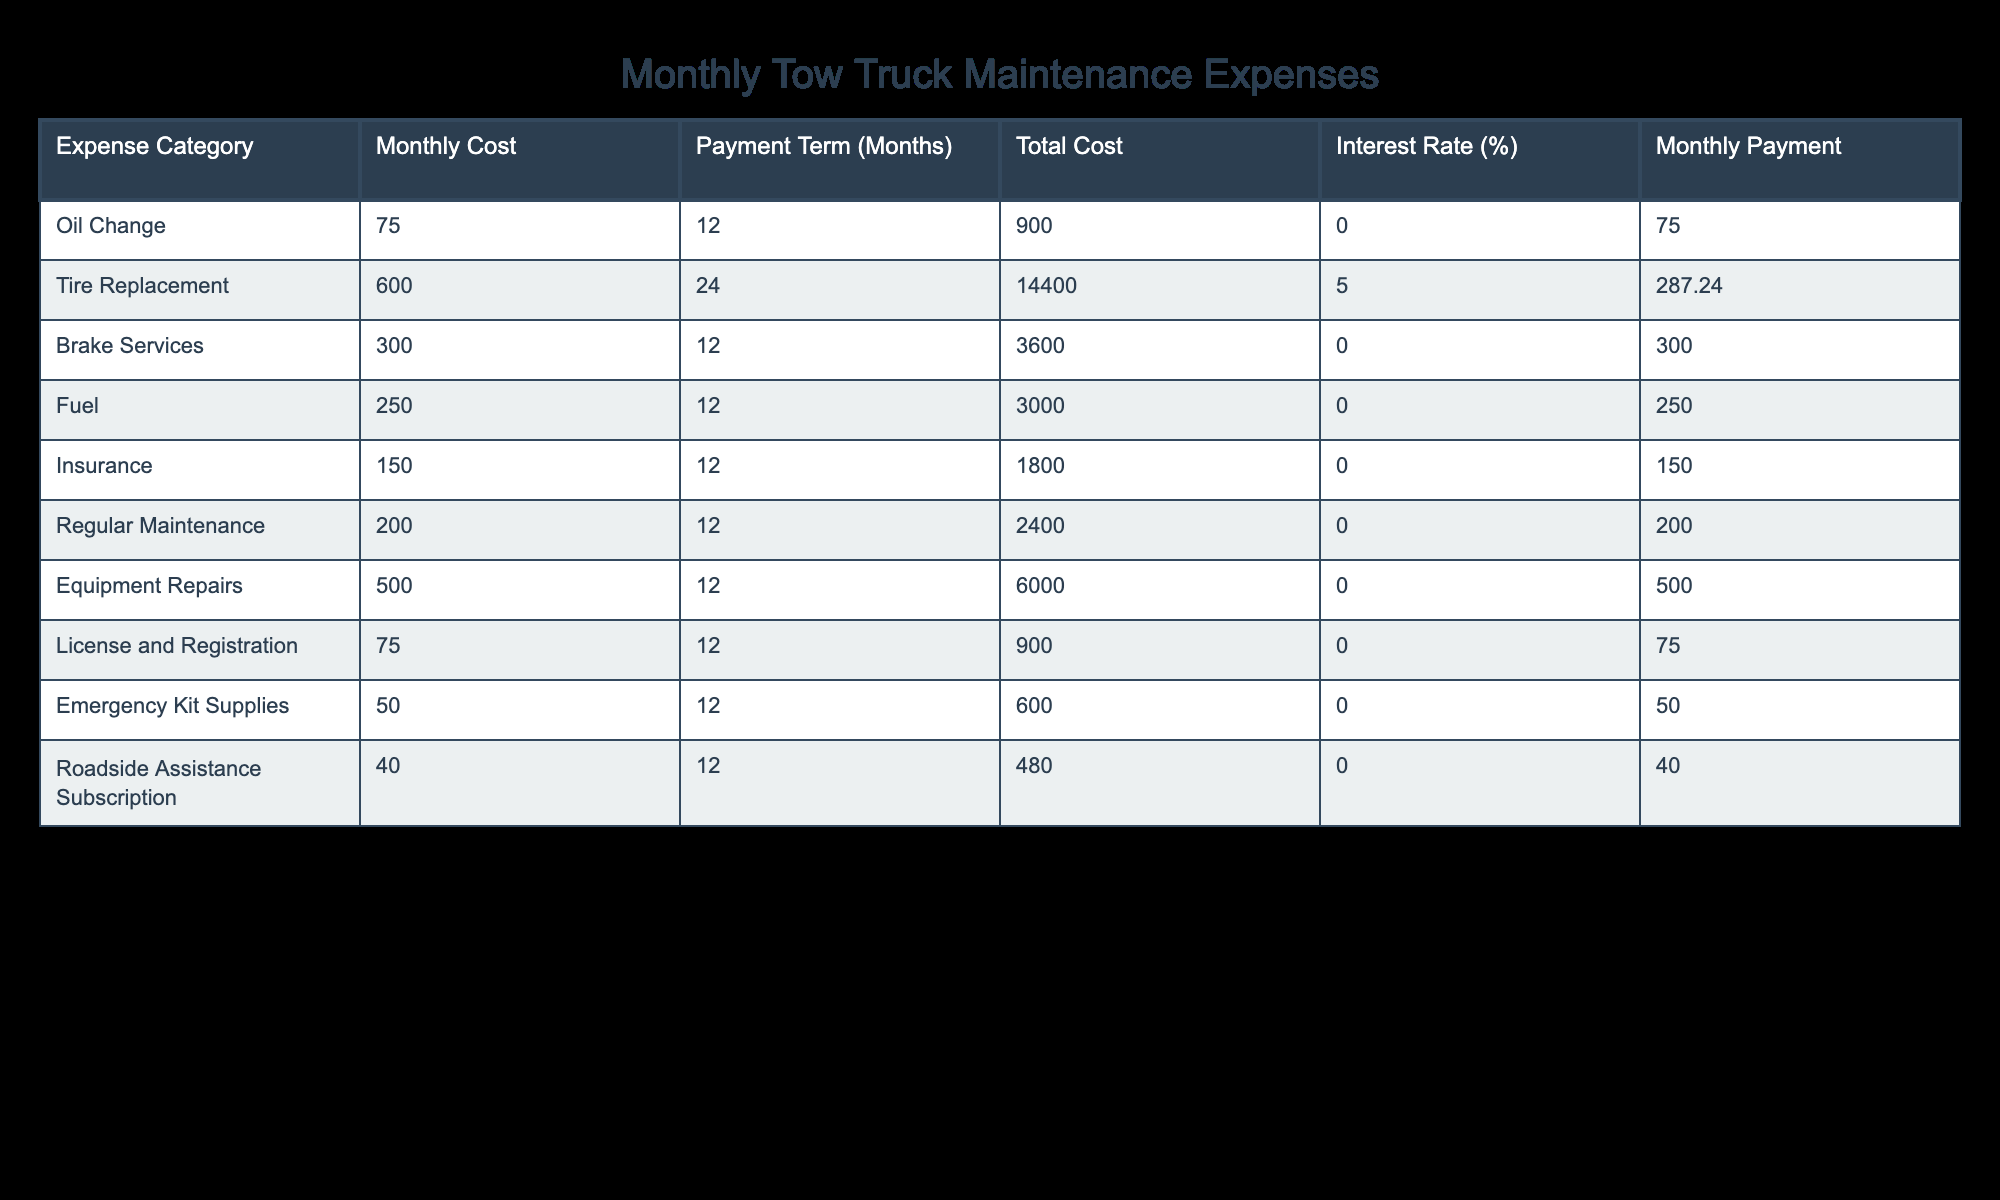What is the monthly payment for tire replacement? The table specifies that the monthly payment for tire replacement is listed under the column "Monthly Payment" for the "Tire Replacement" row. According to the table, this payment is 287.24.
Answer: 287.24 How much do I pay monthly for fuel? Looking at the "Fuel" row in the table, the "Monthly Payment" column indicates that the monthly payment for fuel is 250.
Answer: 250 Which expense category has the highest total cost? We examine the "Total Cost" column for each category and identify the maximum value. The highest total cost is for tire replacement, which is 14,400.
Answer: Tire Replacement What is the average monthly payment across all expense categories? First, we sum all the monthly payments listed: 75 + 287.24 + 300 + 250 + 150 + 200 + 500 + 75 + 50 + 40 = 1877.24. There are 10 categories, so we divide the total (1877.24) by 10 to find the average, which is 187.72.
Answer: 187.72 Is the monthly payment for equipment repairs greater than for oil changes? By comparing the "Monthly Payment" values for "Equipment Repairs" (500) and "Oil Change" (75) from the table, we find that equipment repairs (500) is indeed greater than oil changes (75).
Answer: Yes What is the total of monthly payments for insurance and roadside assistance subscription? We find the monthly payments for both categories: Insurance (150) and Roadside Assistance Subscription (40). Adding these amounts gives us 150 + 40 = 190.
Answer: 190 If I spend the total cost on tire replacement, how much would I pay monthly at an interest rate of 5%? Based on the table, the total cost for tire replacement is 14,400, with an interest rate of 5% and a payment term of 24 months. The monthly payment listed is 287.24, which reflects the cost calculations including interest for this term. Since the question uses provided data, the monthly payment remains 287.24 as stated in the table.
Answer: 287.24 Are the costs of regular maintenance and emergency kit supplies more than the cost of brake services? The costs for regular maintenance (200) and emergency kit supplies (50) add to 250. The cost for brake services is 3,600. Comparing these sums reveals that 250 is less than 3,600.
Answer: No How many categories have a monthly payment less than or equal to 75? By examining the "Monthly Payment" column, we can see that the categories with monthly payments of 75 or less include "Oil Change" (75), and "License and Registration" (75), making a total of 2 categories.
Answer: 2 